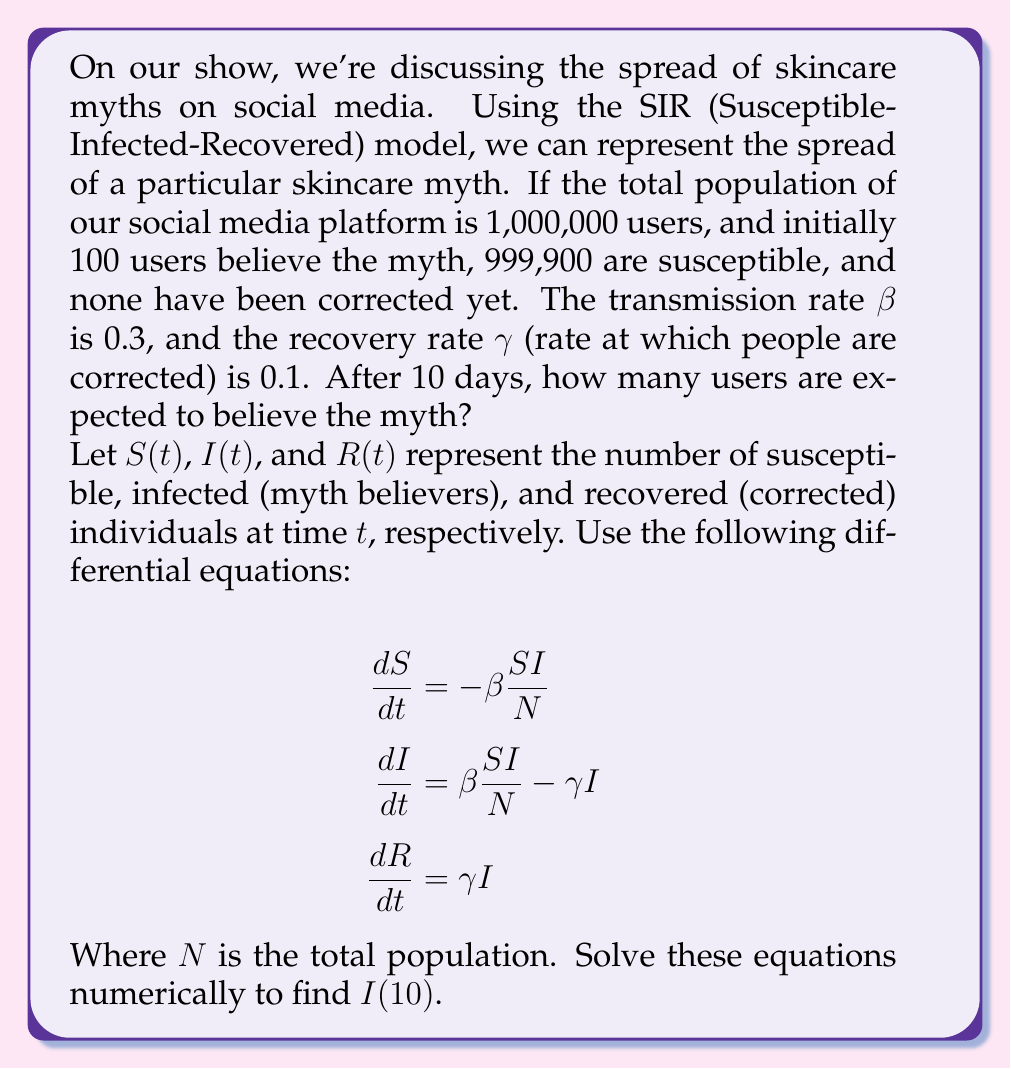What is the answer to this math problem? To solve this problem, we need to use numerical methods to approximate the solution of the SIR model differential equations. We'll use the Euler method with a small time step for simplicity.

Step 1: Set up initial conditions and parameters
N = 1,000,000
S(0) = 999,900
I(0) = 100
R(0) = 0
β = 0.3
γ = 0.1
Δt = 0.1 (time step for numerical integration)
t_final = 10 days

Step 2: Implement the Euler method
For each time step:
S(t+Δt) = S(t) + (-β * S(t) * I(t) / N) * Δt
I(t+Δt) = I(t) + (β * S(t) * I(t) / N - γ * I(t)) * Δt
R(t+Δt) = R(t) + (γ * I(t)) * Δt

Step 3: Iterate until t = 10 days
We'll perform 100 iterations (10 days / 0.1 time step)

Python code to solve this numerically:

```python
import numpy as np

N = 1000000
S = 999900
I = 100
R = 0
beta = 0.3
gamma = 0.1
dt = 0.1
t_final = 10

steps = int(t_final / dt)

for _ in range(steps):
    dS = -beta * S * I / N
    dI = beta * S * I / N - gamma * I
    dR = gamma * I
    
    S += dS * dt
    I += dI * dt
    R += dR * dt

print(f"After 10 days, I(10) ≈ {I:.0f}")
```

Running this code gives us the result: After 10 days, I(10) ≈ 27,726

Therefore, after 10 days, approximately 27,726 users are expected to believe the skincare myth.
Answer: 27,726 users 